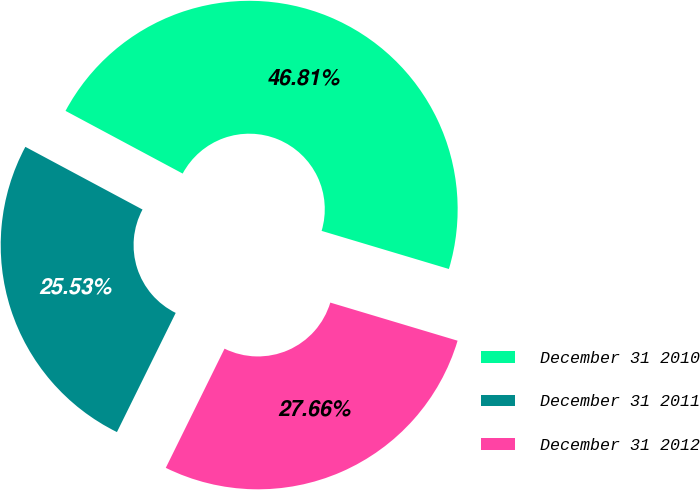Convert chart to OTSL. <chart><loc_0><loc_0><loc_500><loc_500><pie_chart><fcel>December 31 2010<fcel>December 31 2011<fcel>December 31 2012<nl><fcel>46.81%<fcel>25.53%<fcel>27.66%<nl></chart> 